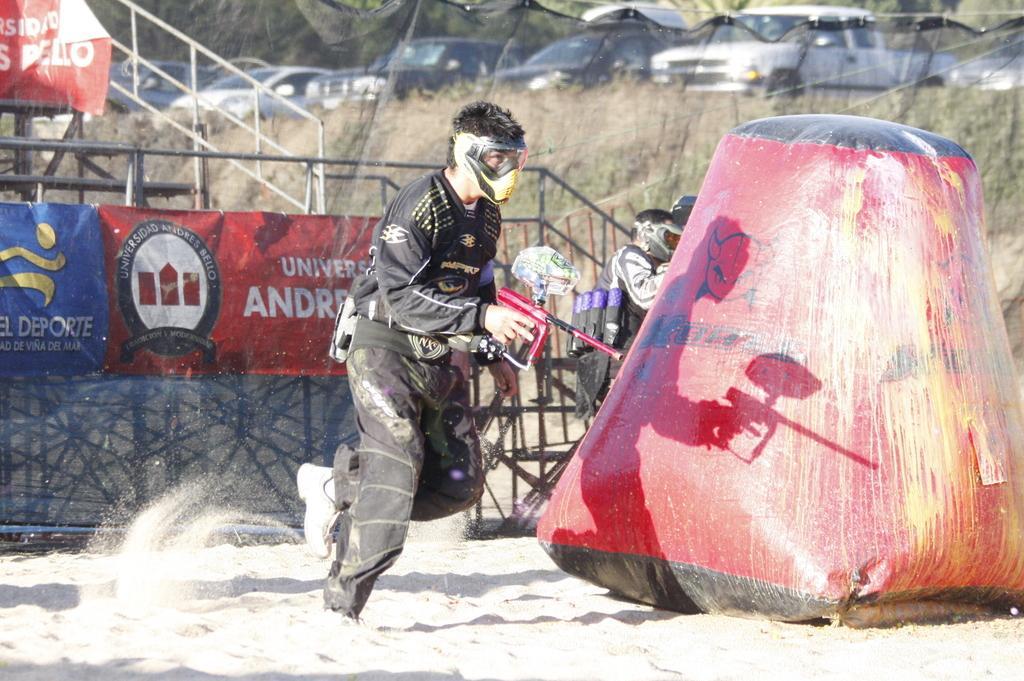Can you describe this image briefly? In this image I can see a person wearing black color dress is standing and holding a red and black colored object. I can see a huge red and black colored object on the ground, few banners which are red and blue in color, few persons and the railing. In the background I can see few vehicles and few trees. 